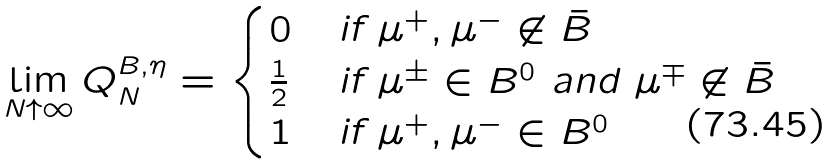<formula> <loc_0><loc_0><loc_500><loc_500>\lim _ { N \uparrow \infty } Q _ { N } ^ { B , \eta } = \begin{cases} 0 & \text {if } \mu ^ { + } , \mu ^ { - } \not \in \bar { B } \\ \frac { 1 } { 2 } & \text {if } \mu ^ { \pm } \in B ^ { 0 } \text { and } \mu ^ { \mp } \not \in \bar { B } \\ 1 & \text {if } \mu ^ { + } , \mu ^ { - } \in B ^ { 0 } \end{cases}</formula> 